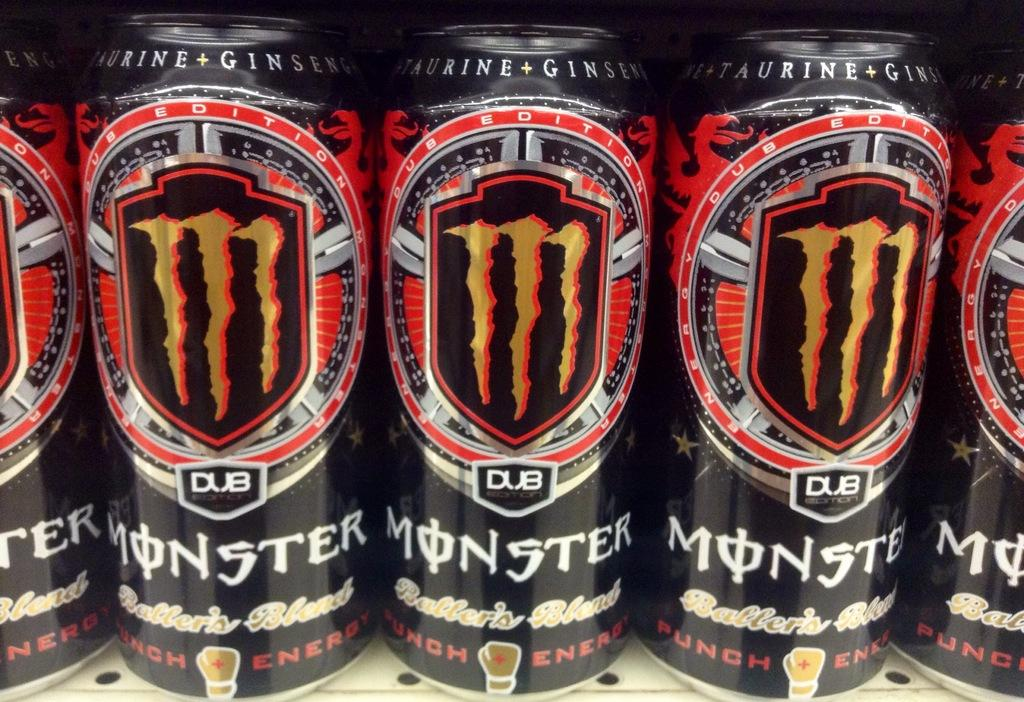<image>
Describe the image concisely. Several cans of Monster energy are lined up in a row. 